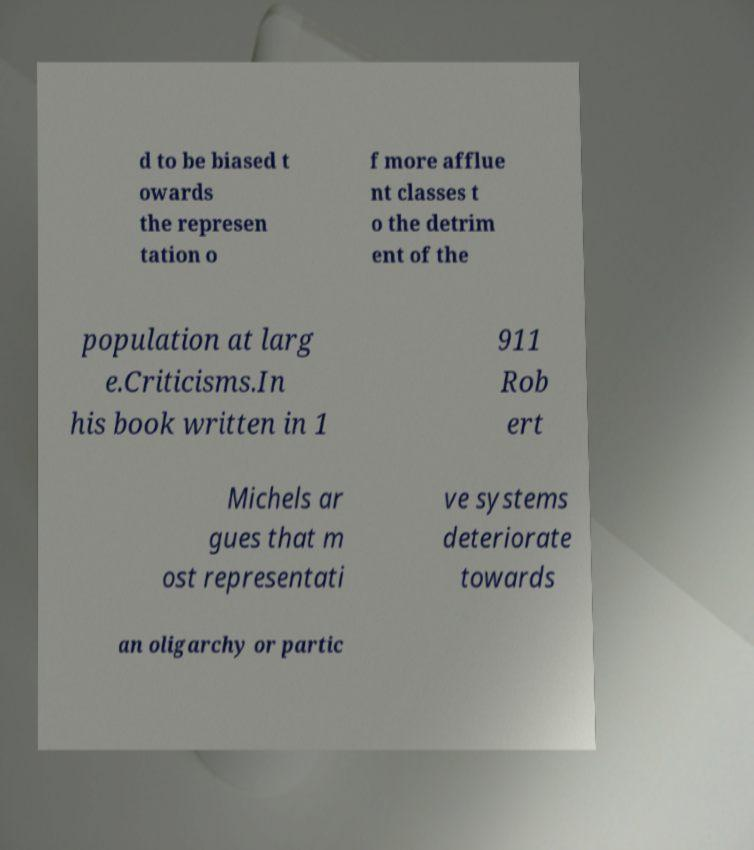Could you assist in decoding the text presented in this image and type it out clearly? d to be biased t owards the represen tation o f more afflue nt classes t o the detrim ent of the population at larg e.Criticisms.In his book written in 1 911 Rob ert Michels ar gues that m ost representati ve systems deteriorate towards an oligarchy or partic 